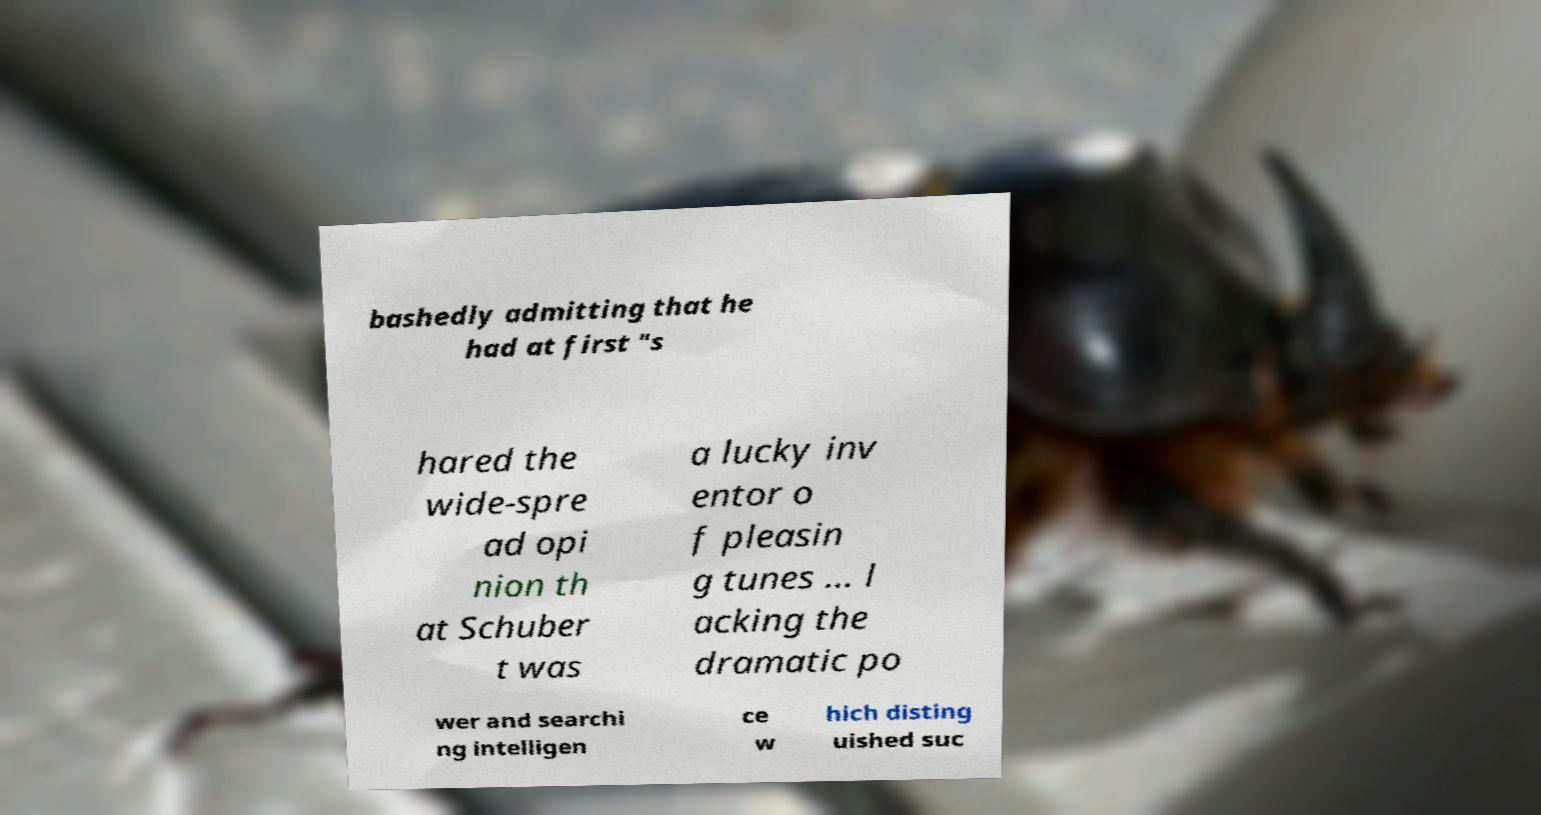Could you assist in decoding the text presented in this image and type it out clearly? bashedly admitting that he had at first "s hared the wide-spre ad opi nion th at Schuber t was a lucky inv entor o f pleasin g tunes ... l acking the dramatic po wer and searchi ng intelligen ce w hich disting uished suc 